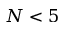<formula> <loc_0><loc_0><loc_500><loc_500>N < 5</formula> 